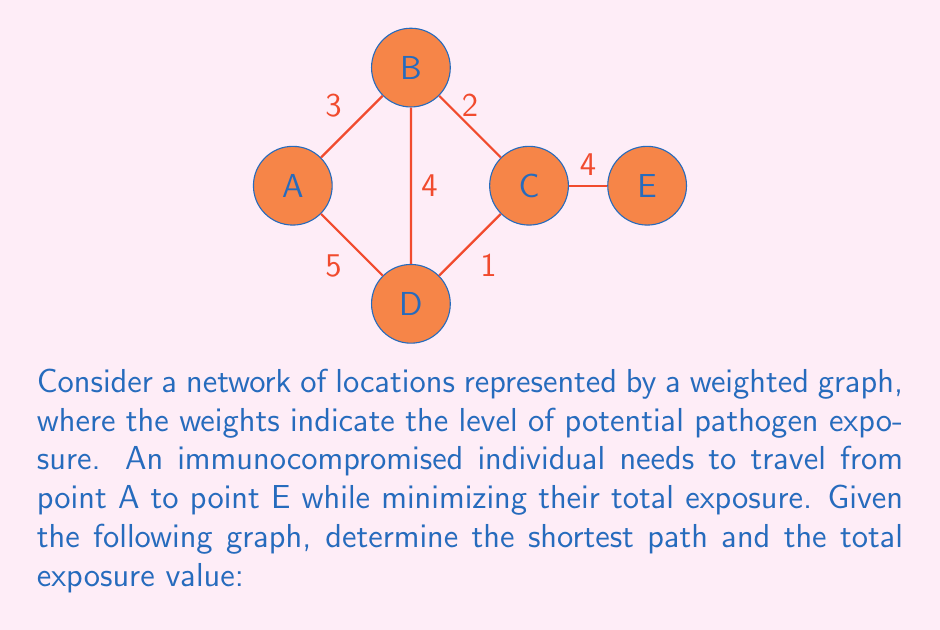Provide a solution to this math problem. To solve this problem, we can use Dijkstra's algorithm to find the shortest path in a weighted graph. Here's a step-by-step approach:

1) Initialize:
   - Set distance to A as 0 and all other nodes as infinity.
   - Set all nodes as unvisited.
   - Set A as the current node.

2) For the current node, consider all unvisited neighbors and calculate their tentative distances:
   - A to B: 0 + 3 = 3
   - A to D: 0 + 5 = 5

3) Update the neighbor's distance if the calculated distance is less than the previously recorded distance.

4) Mark the current node as visited. A is now visited.

5) Select the unvisited node with the smallest tentative distance as the new current node. B becomes the current node.

6) Repeat steps 2-5:
   - B to C: 3 + 2 = 5
   - B to D: 3 + 4 = 7 (greater than current D value, so not updated)

7) C becomes the current node:
   - C to E: 5 + 4 = 9

8) D becomes the current node:
   - D to C: 5 + 1 = 6 (less than current C value, update C)
   - C to E: 6 + 4 = 10 (greater than current E value, so not updated)

9) E is the last node to be visited.

The shortest path is A → B → C → E with a total exposure value of 9.

$$\text{Total Exposure} = d_{AB} + d_{BC} + d_{CE} = 3 + 2 + 4 = 9$$

Where $d_{XY}$ represents the distance (exposure level) between points X and Y.
Answer: The shortest path is A → B → C → E with a total exposure value of 9. 